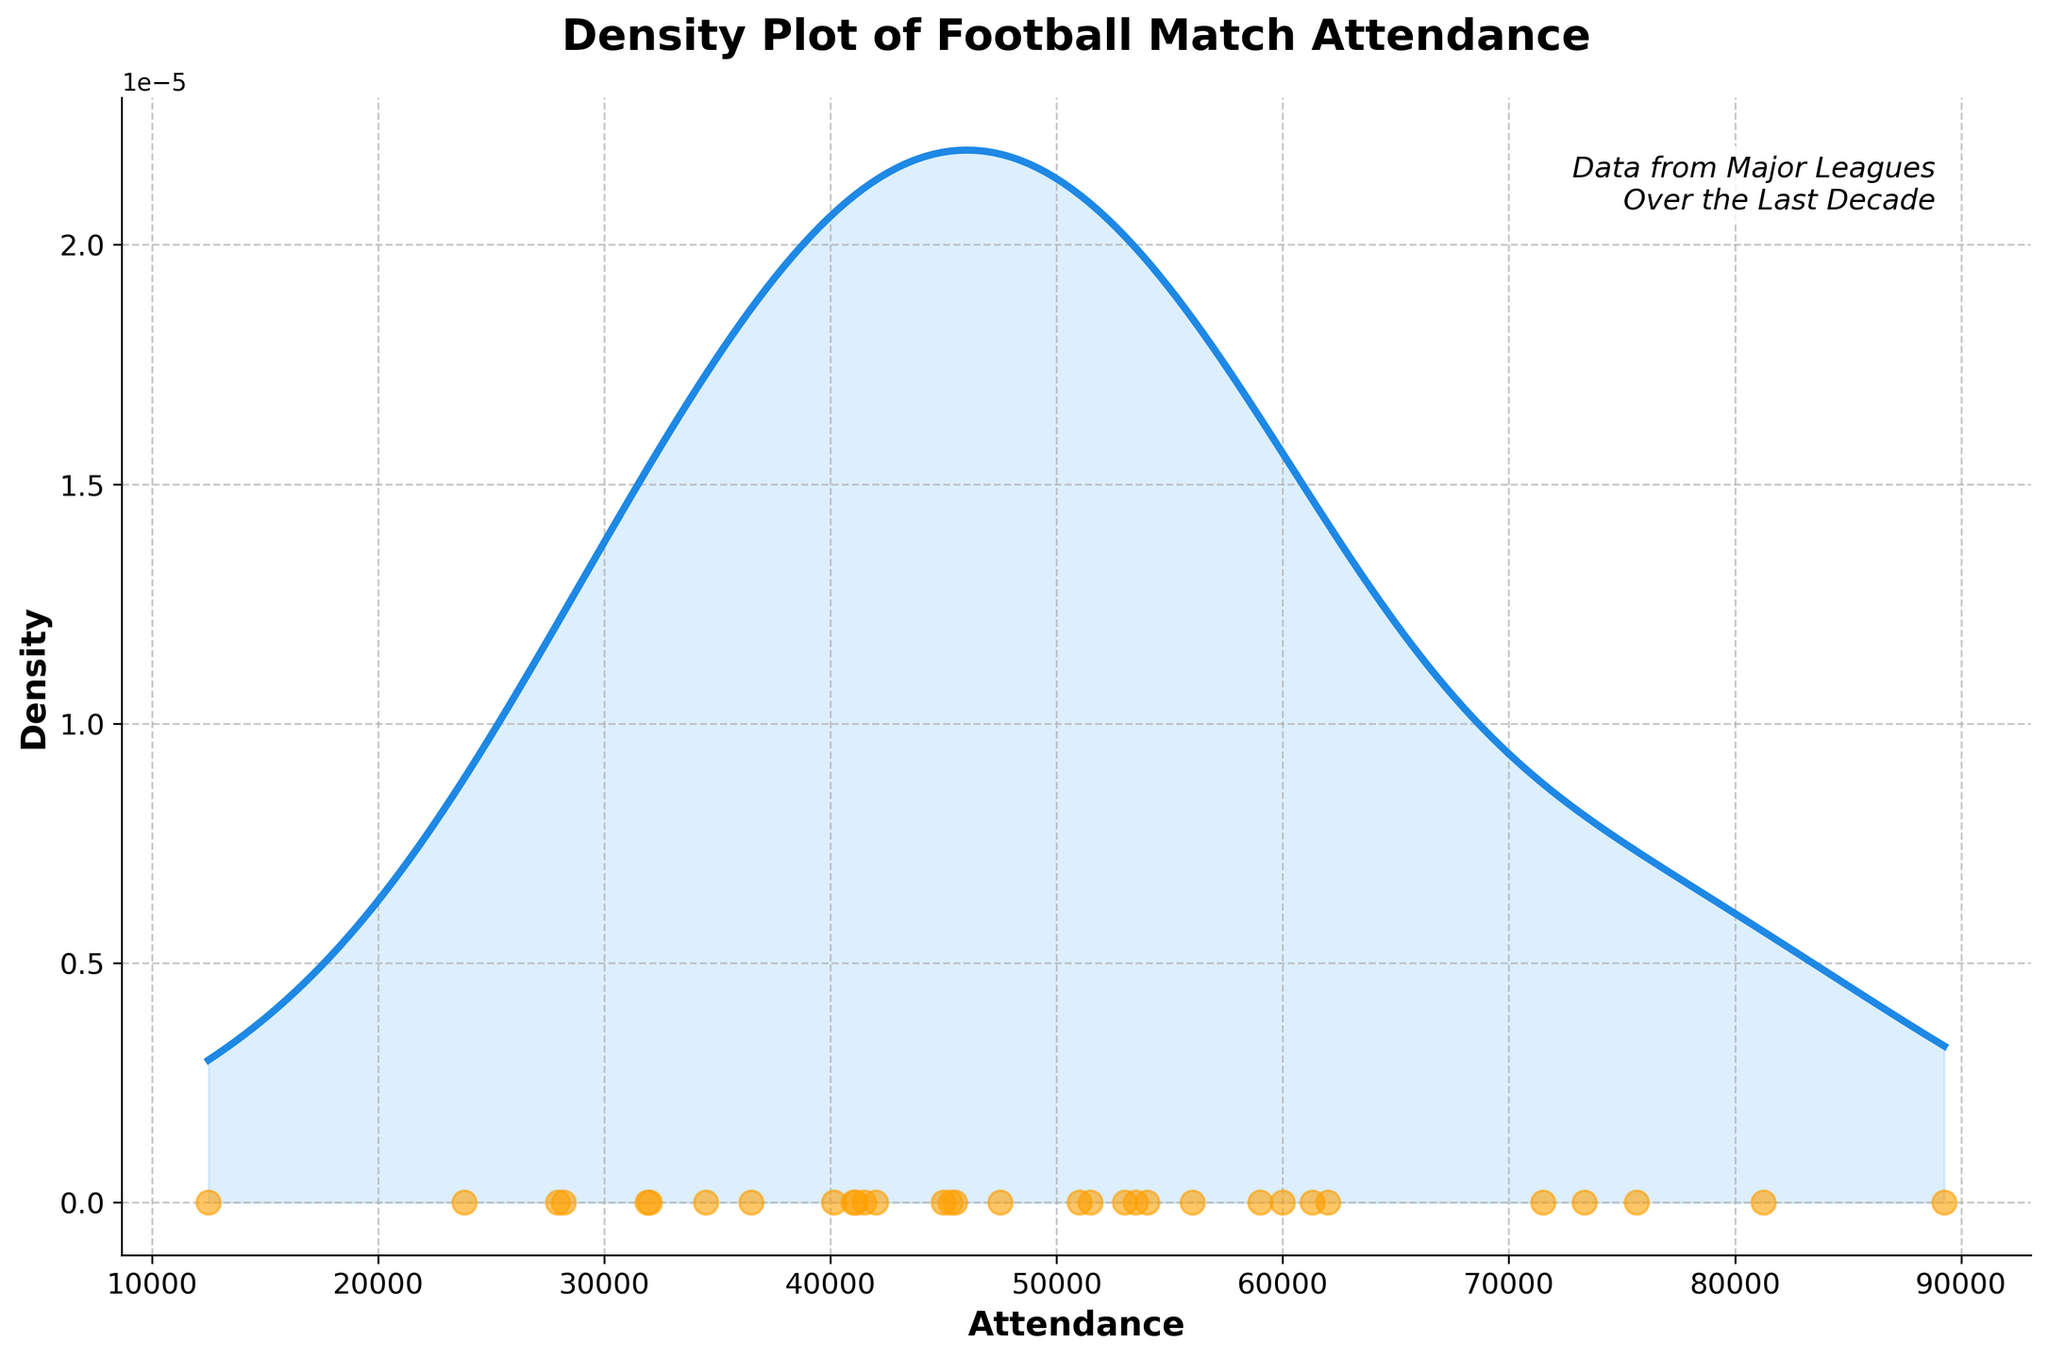What is the title of the plot? The title of the plot is stated at the top of the figure. It reads "Density Plot of Football Match Attendance".
Answer: Density Plot of Football Match Attendance What is the range of the attendance values shown on the x-axis? The x-axis range is from the minimum to the maximum attendance values recorded in the dataset. By examining the plot, the x-axis starts around 12,500 and ends just above 89,000.
Answer: 12,500 to 89,000 Which color represents the density plot line? The density plot line is represented by a solid color line. In the plot, this color is a shade of blue.
Answer: Blue How many peaks (modes) are evident in the density plot? Peaks or modes in a density plot are represented by the highest points of the curve. The plot shows one clear peak or mode towards the high attendance values.
Answer: One What does the scatter plot overlaid on the density plot represent? The overlaid scatter plot likely represents individual attendance values for different matches. Each point corresponds to a specific attendance record.
Answer: Individual attendance values Which range of attendance values has the highest density according to the plot? The highest density is found where the density plot's peak is located. This peak indicates the most frequent attendance values, which is around 70,000 to 80,000.
Answer: 70,000 to 80,000 What can you infer about the distribution of attendance from the density plot's shape? The shape of the density plot indicates the distribution of attendance values. Since there is a single peak (unimodal) around 70,000 to 80,000, most matches have attendance values around this range. The plot also tails off towards both the lower and higher attendance values, hinting that fewer matches have extreme attendance numbers.
Answer: Most matches have attendance around 70,000 to 80,000 Compare the density of the lowest and highest attendance values. Which is greater? The density at any given point can be inferred from the height of the density plot. The density at the lowest attendance value (around 12,500) is almost zero compared to the highest attendance values (>80,000), where the density is higher but still lower than the peak.
Answer: Highest attendance values Estimate the approximate attendance for matches that appear less frequently, as suggested by low-density regions. Low-density regions are represented by flatter areas of the density plot. The regions with fewer matches have attendance values roughly below 40,000 and above 80,000.
Answer: Below 40,000 and above 80,000 How does the scatter plot help in understanding the density plot? The scatter plot gives the actual distribution of attendance records. While the density plot provides a smooth estimate of where most values lie, the scatter plot shows exact attendance numbers, making it easier to understand the individual data points contributing to the density.
Answer: Shows individual attendance values 